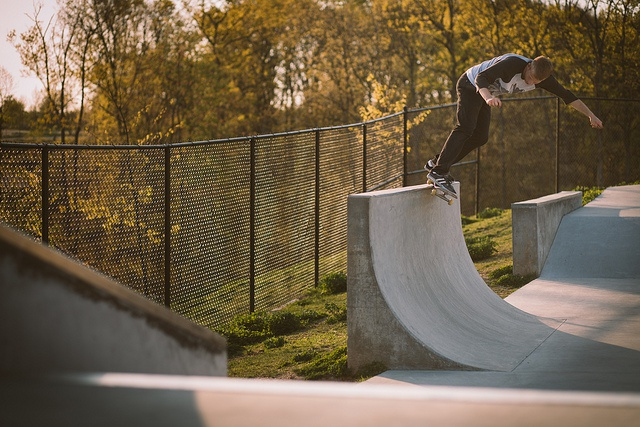Describe the objects in this image and their specific colors. I can see people in lightgray, black, gray, and maroon tones and skateboard in lightgray, gray, and darkgray tones in this image. 